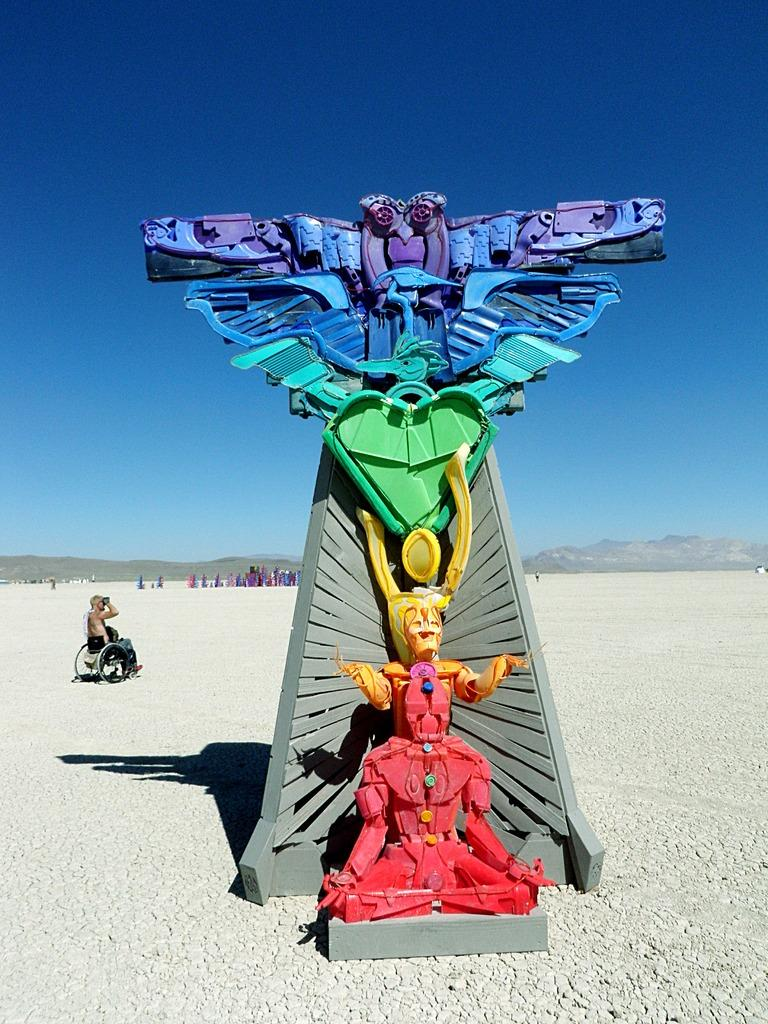What is the main subject in the center of the image? There is a sculpture in the center of the image. Who or what is located on the left side of the image? There is a person sitting on a wheelchair on the left side of the image. What can be seen in the background of the image? There are people and hills visible in the background of the image. What is visible above the hills in the image? The sky is visible in the background of the image. Where is the key to unlock the hydrant in the image? There is no key or hydrant present in the image. 